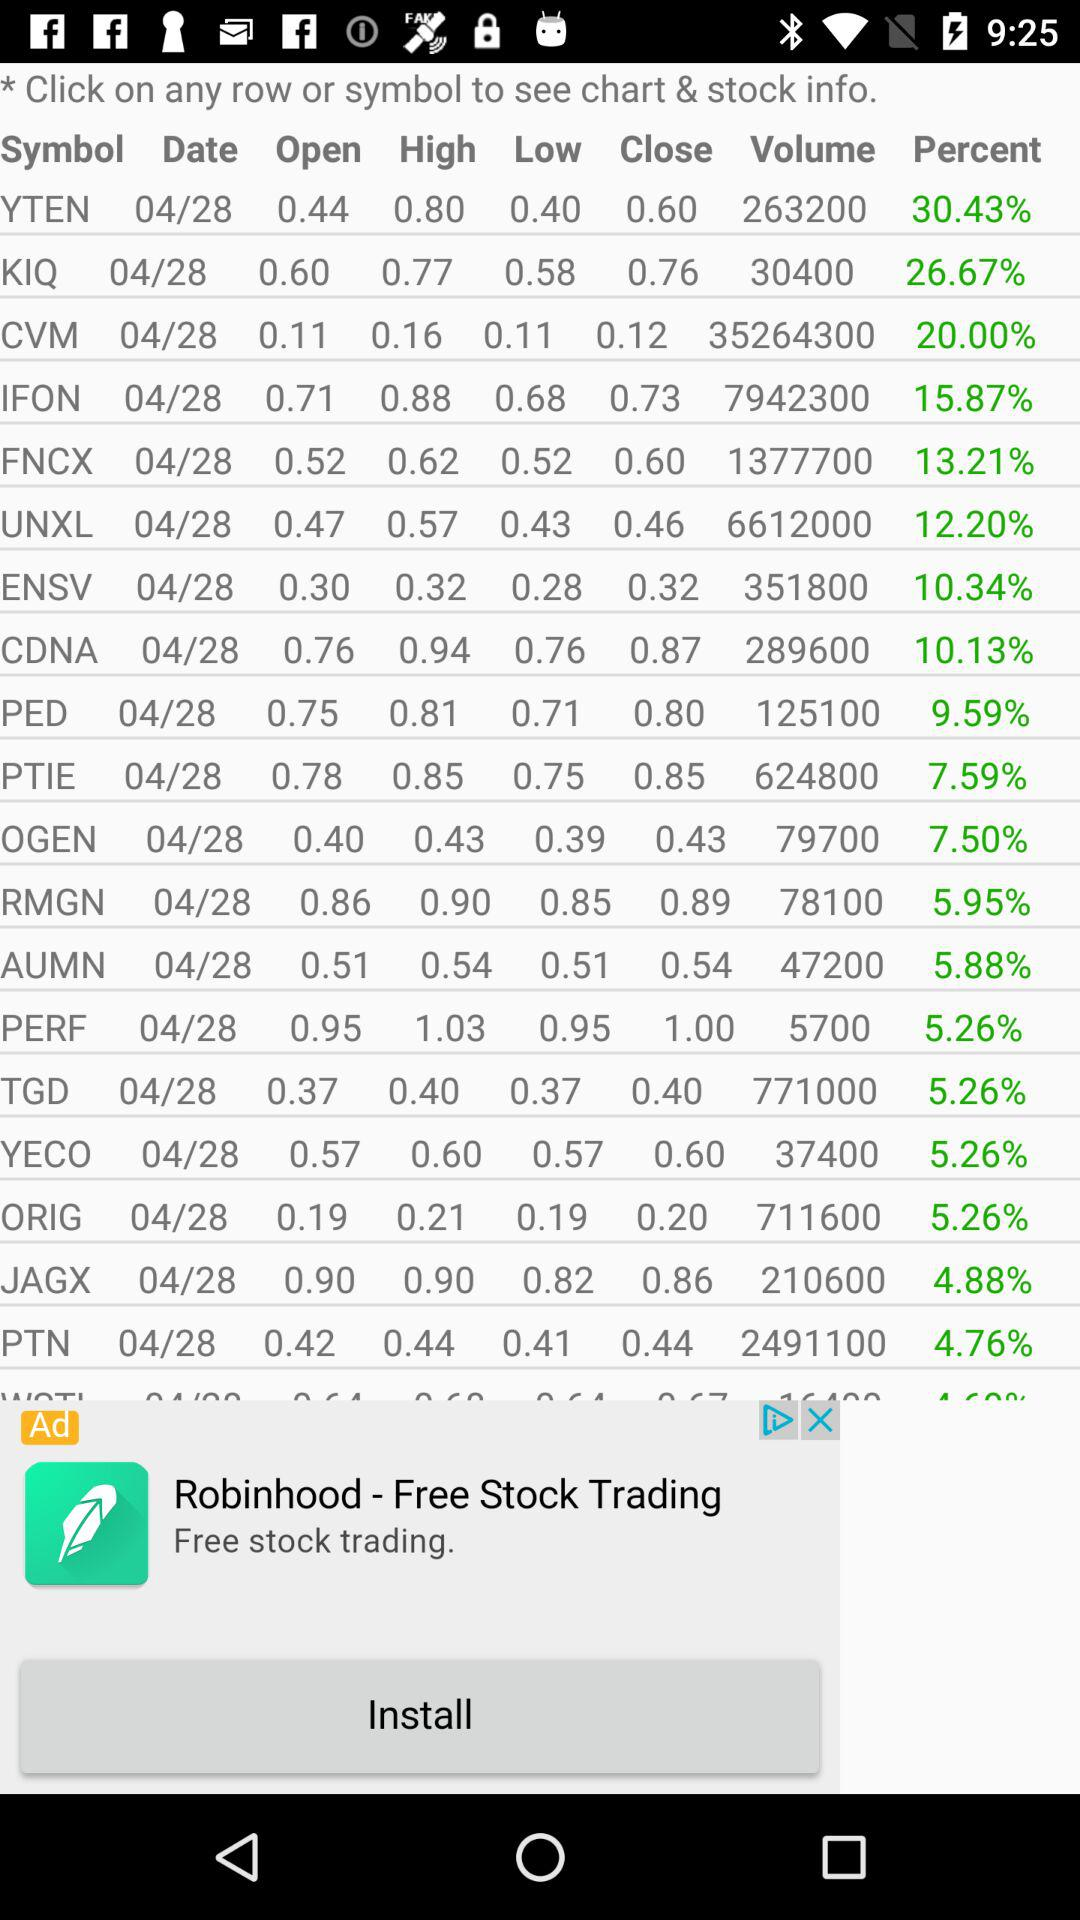What is the stock volume of "FNCX"? The stock volume of "FNCX" is 1377700. 